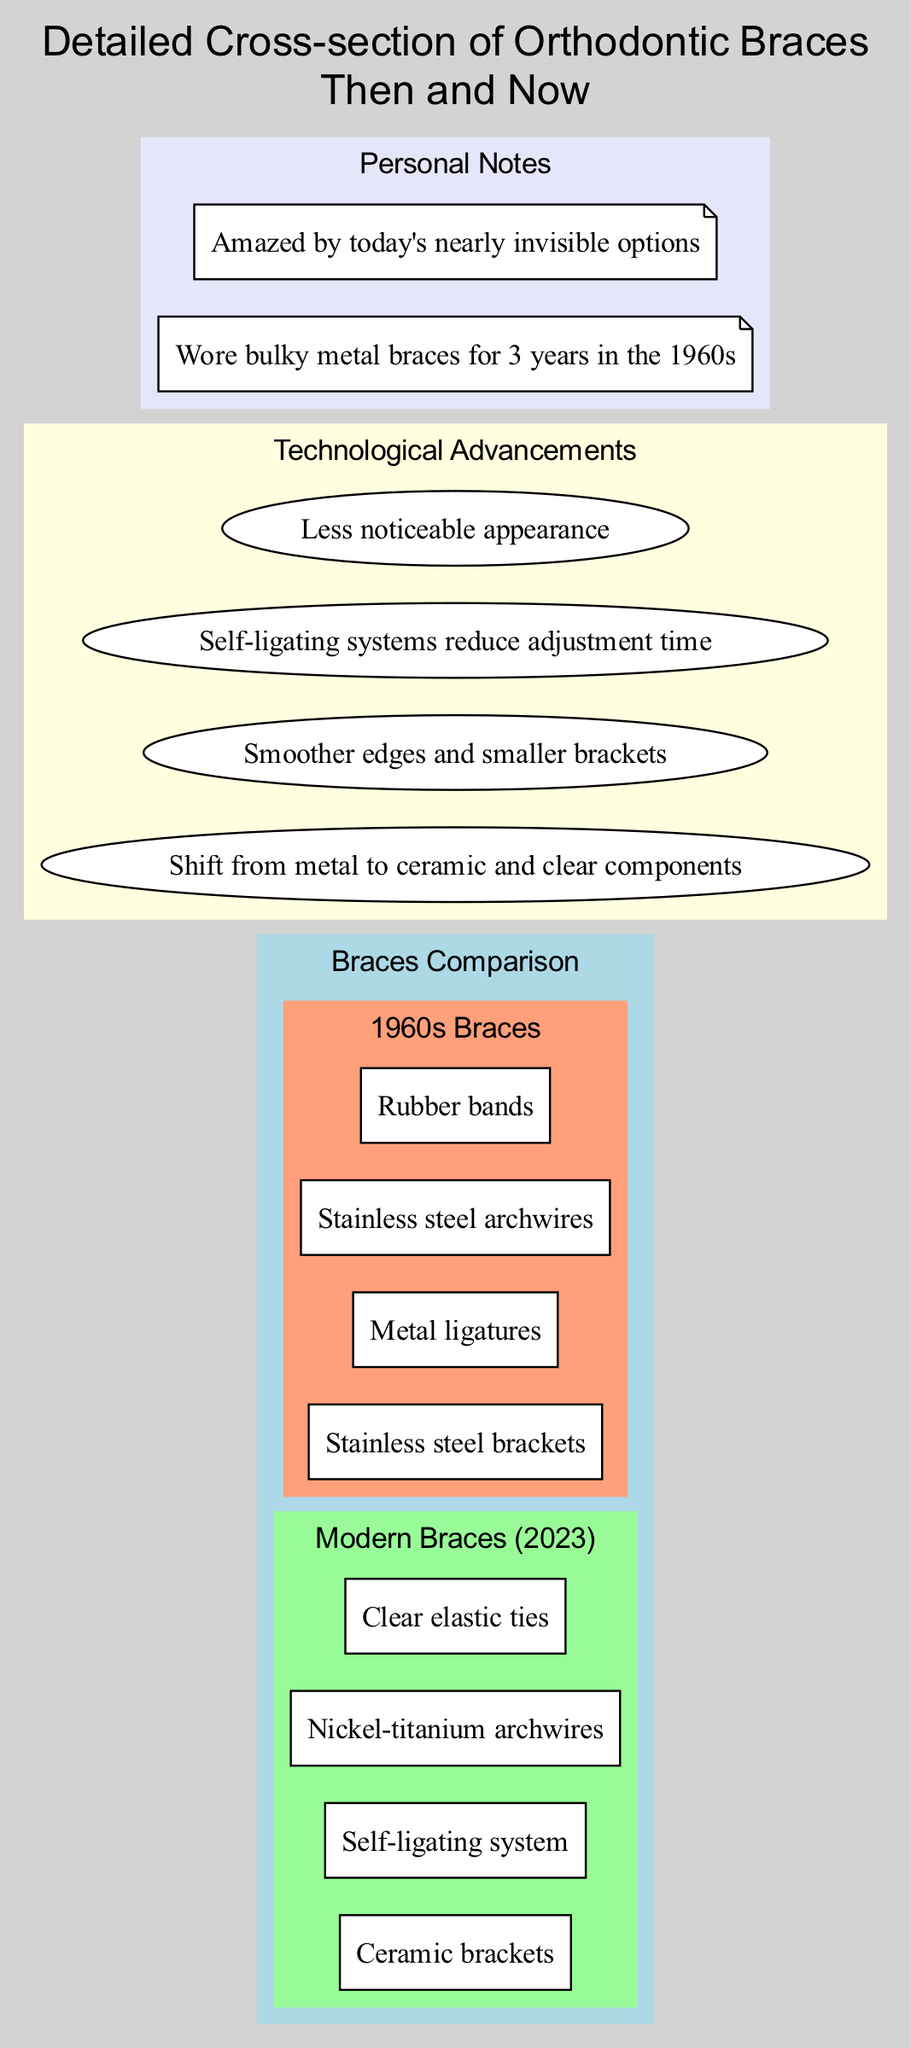What are the sub-components of modern braces? The diagram lists "Ceramic brackets," "Self-ligating system," "Nickel-titanium archwires," and "Clear elastic ties" under modern braces.
Answer: Ceramic brackets, Self-ligating system, Nickel-titanium archwires, Clear elastic ties How many main components are compared in the diagram? The diagram has two main components: "Modern Braces (2023)" and "1960s Braces."
Answer: 2 What material shift is highlighted in the technological advancements? The technological advancement section mentions a shift from metal to ceramic and clear components.
Answer: Metal to ceramic and clear components What is the description of the efficiency improvement in modern braces? The diagram states that self-ligating systems reduce adjustment time under the efficiency technological advancement.
Answer: Self-ligating systems reduce adjustment time How do modern braces differ aesthetically from those of the 1960s? The advanced section mentions that modern braces offer a less noticeable appearance compared to the bulky options of the 1960s.
Answer: Less noticeable appearance What component is used for ligation in 1960s braces? The sub-components of 1960s braces include "Metal ligatures" for ligation.
Answer: Metal ligatures How many sub-components are listed for 1960s braces? The section for 1960s braces includes four sub-components: "Stainless steel brackets," "Metal ligatures," "Stainless steel archwires," and "Rubber bands."
Answer: 4 What personal note reflects surprise at modern braces? The personal note "Amazed by today's nearly invisible options" expresses surprise and admiration for modern braces.
Answer: Amazed by today's nearly invisible options 